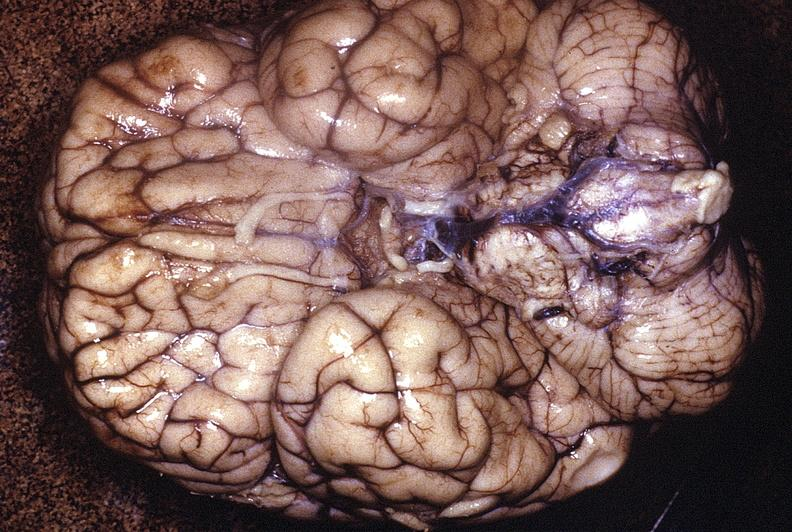s adrenal of premature 30 week gestation gram infant lesion present?
Answer the question using a single word or phrase. No 